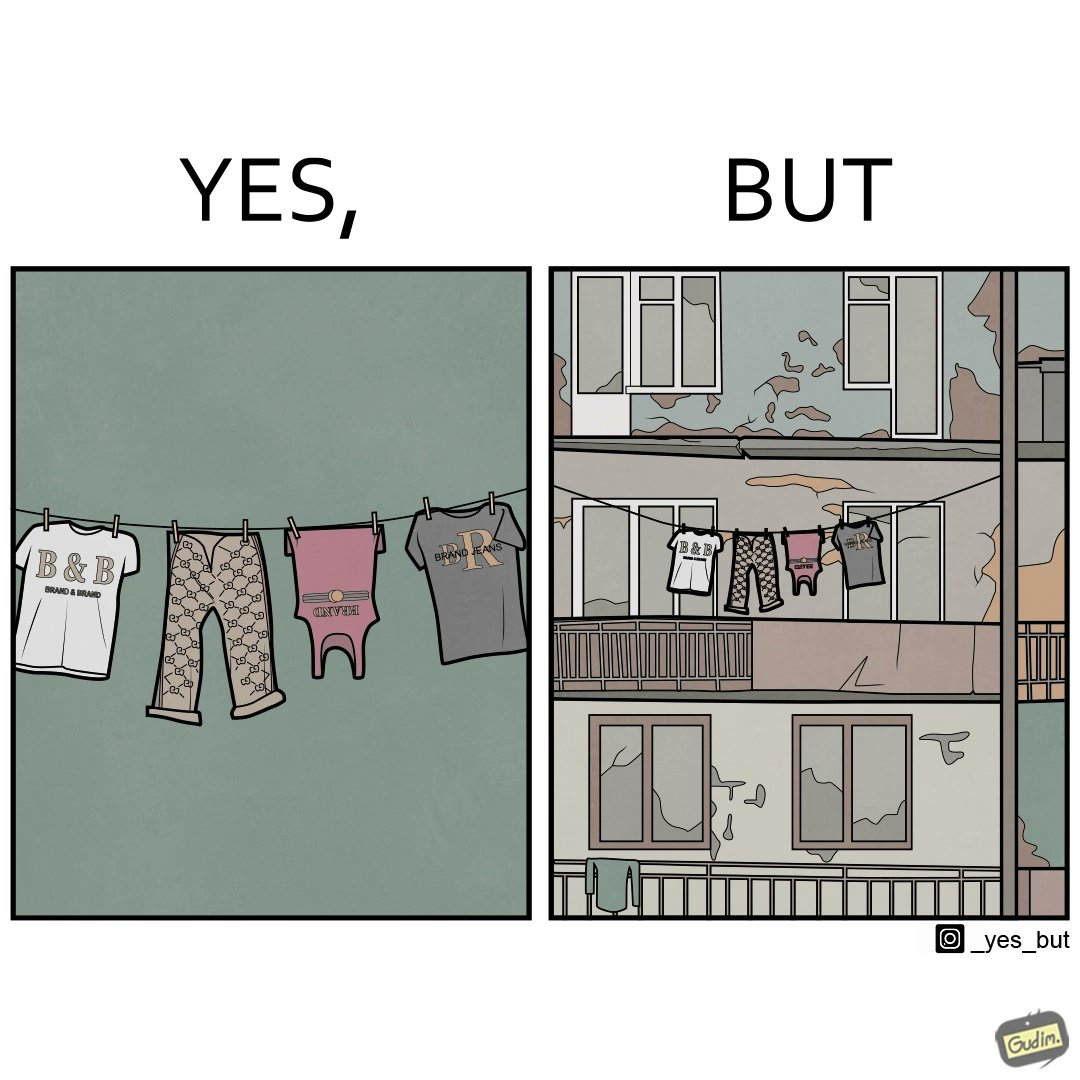What does this image depict? The image is ironic because although the clothes are of branded companies but they are hanging in very poor building. 